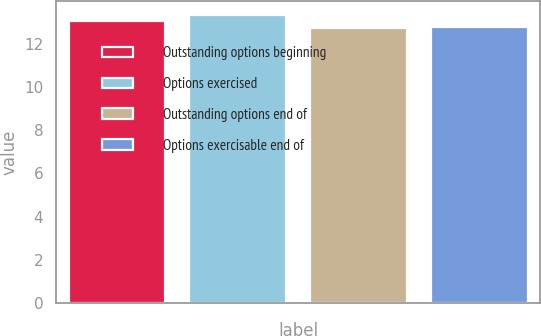Convert chart. <chart><loc_0><loc_0><loc_500><loc_500><bar_chart><fcel>Outstanding options beginning<fcel>Options exercised<fcel>Outstanding options end of<fcel>Options exercisable end of<nl><fcel>13.06<fcel>13.32<fcel>12.71<fcel>12.77<nl></chart> 